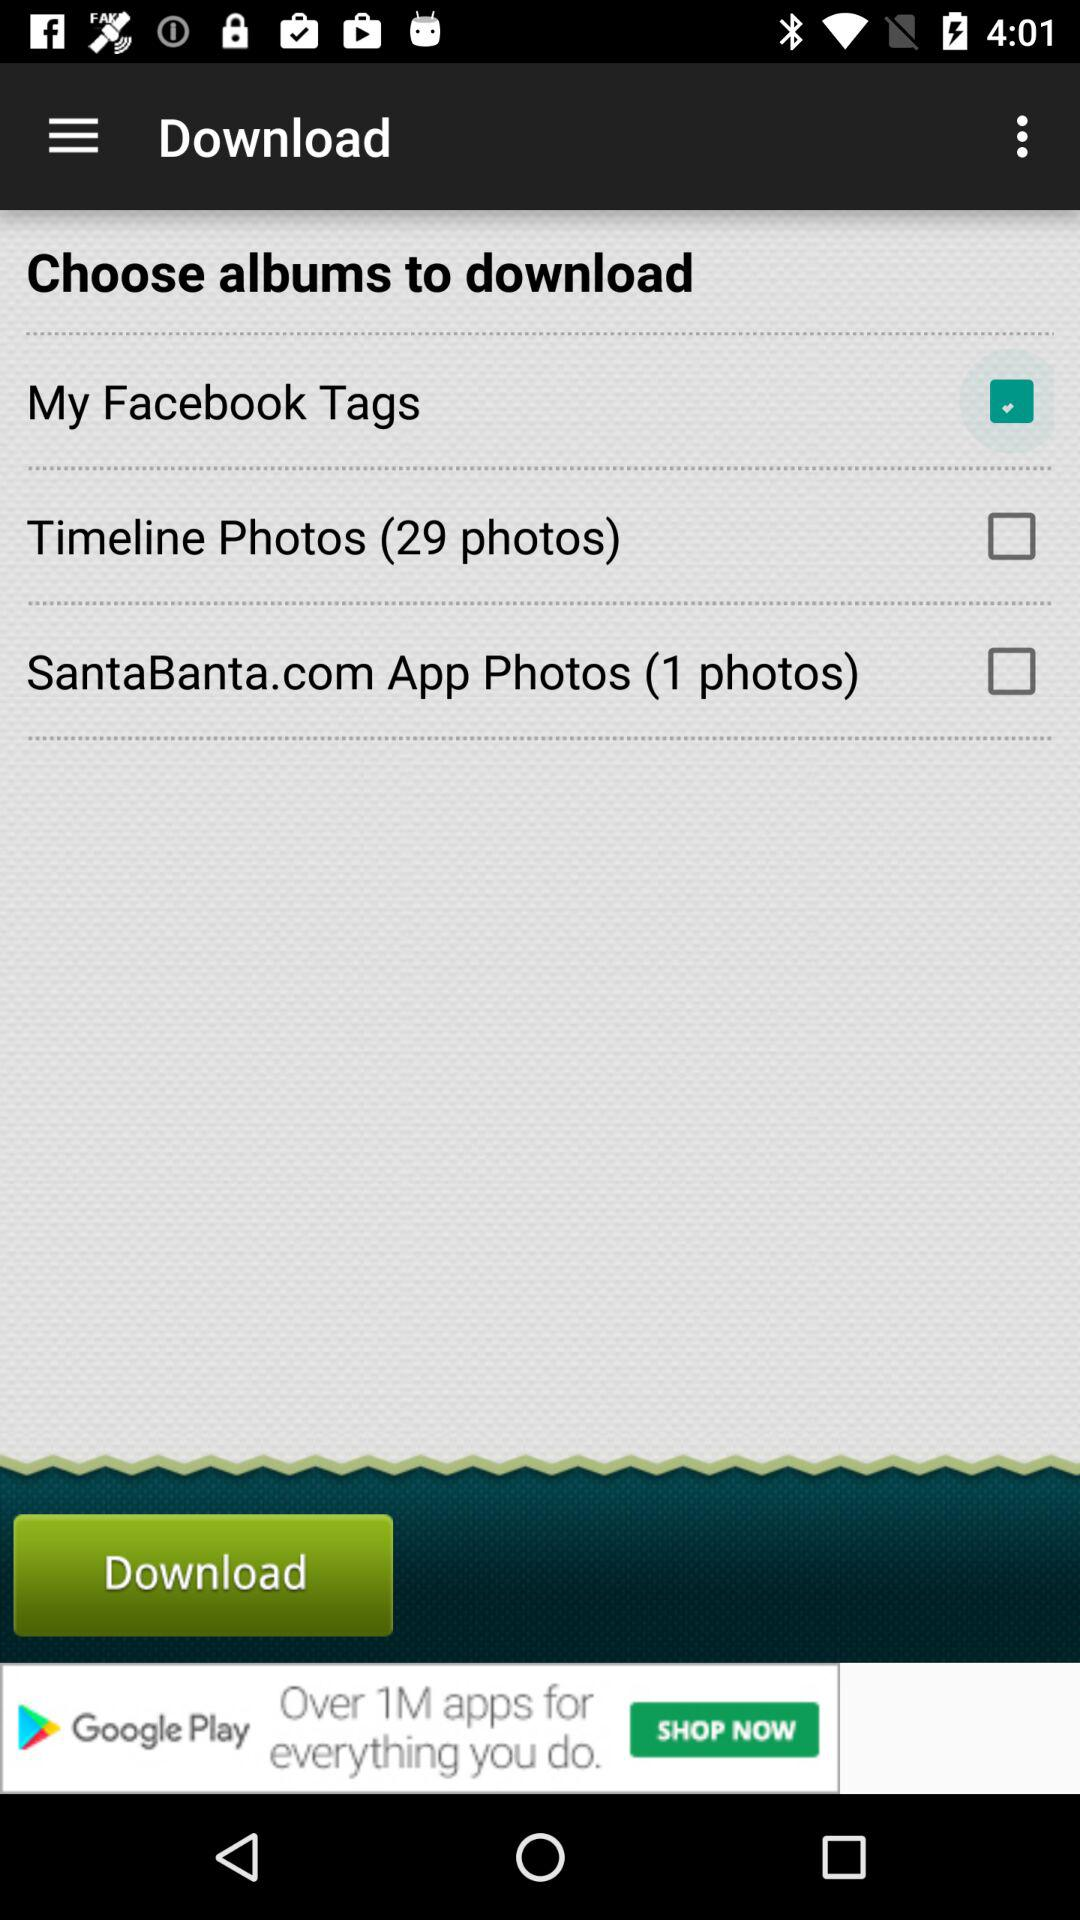How many photos are in the SantaBanta.com App Photos album?
Answer the question using a single word or phrase. 1 